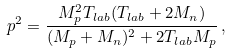<formula> <loc_0><loc_0><loc_500><loc_500>p ^ { 2 } = \frac { M _ { p } ^ { 2 } T _ { l a b } ( T _ { l a b } + 2 M _ { n } ) } { ( M _ { p } + M _ { n } ) ^ { 2 } + 2 T _ { l a b } M _ { p } } \, ,</formula> 